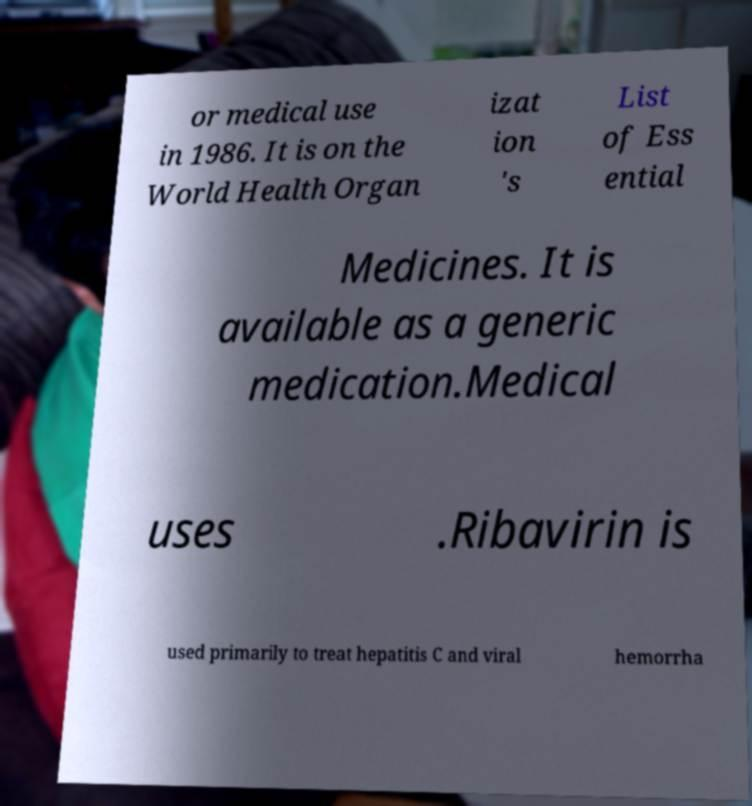What messages or text are displayed in this image? I need them in a readable, typed format. or medical use in 1986. It is on the World Health Organ izat ion 's List of Ess ential Medicines. It is available as a generic medication.Medical uses .Ribavirin is used primarily to treat hepatitis C and viral hemorrha 